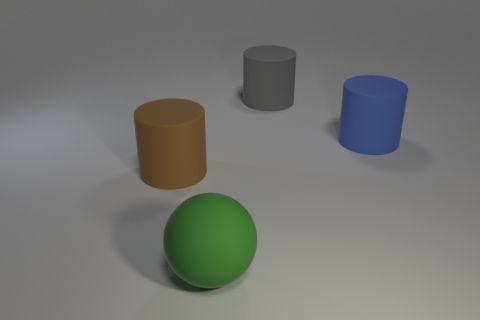Add 2 green metallic spheres. How many objects exist? 6 Subtract all cylinders. How many objects are left? 1 Subtract 0 blue spheres. How many objects are left? 4 Subtract all gray objects. Subtract all gray rubber things. How many objects are left? 2 Add 1 cylinders. How many cylinders are left? 4 Add 4 objects. How many objects exist? 8 